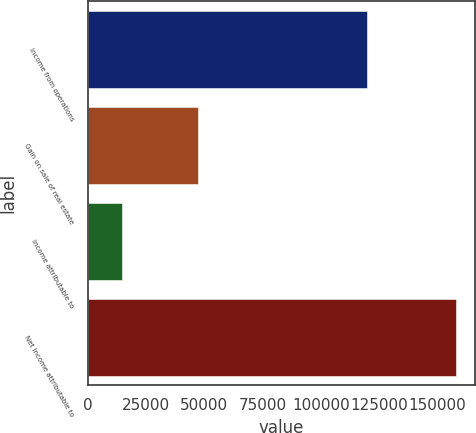Convert chart to OTSL. <chart><loc_0><loc_0><loc_500><loc_500><bar_chart><fcel>Income from operations<fcel>Gain on sale of real estate<fcel>Income attributable to<fcel>Net income attributable to<nl><fcel>119671<fcel>47321<fcel>14643<fcel>158246<nl></chart> 